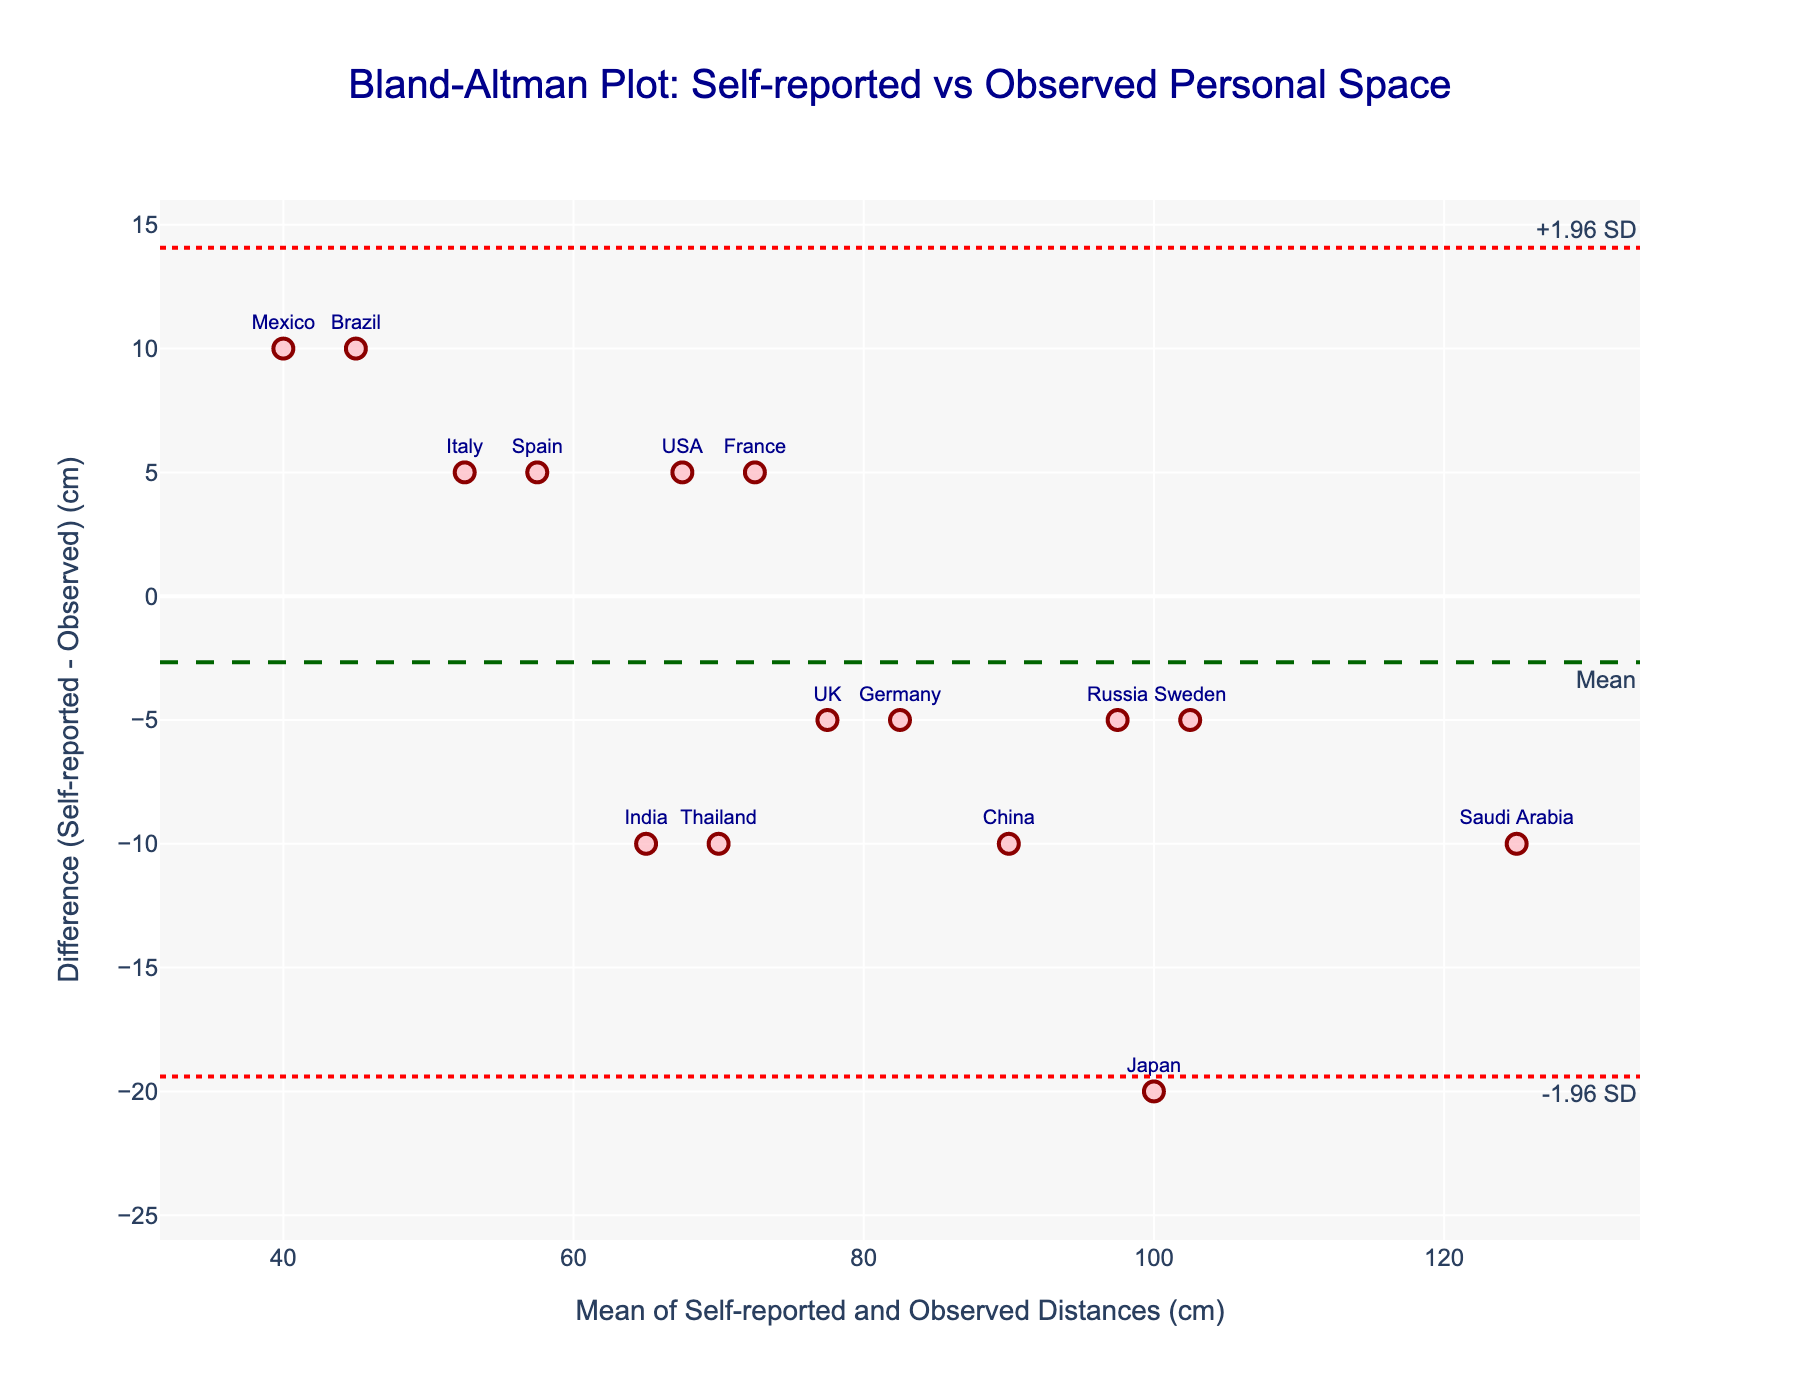What is the title of the figure? The title is prominently displayed at the top of the figure in larger font and blue color.
Answer: Bland-Altman Plot: Self-reported vs Observed Personal Space What does the x-axis represent? The x-axis title can be seen below the axis, describing what it measures in the plot.
Answer: Mean of Self-reported and Observed Distances (cm) What does the y-axis represent? The y-axis title is found on the left side of the axis, explaining the measurement used on this axis.
Answer: Difference (Self-reported - Observed) (cm) How many data points are there in the figure? By counting the number of markers or cultures listed, we determine the number of data points.
Answer: 15 Which culture has the smallest observed personal space compared to its self-reported distance? We identify the culture with the largest negative difference by looking at the y-axis values labeled with culture names.
Answer: Mexico Which culture has the highest mean distance between self-reported and observed distances? By determining which data point has the highest x-axis value, representing the mean distance.
Answer: Saudi Arabia What is the mean difference between self-reported and observed distances? The mean difference is indicated by a dashed horizontal line labeled "Mean".
Answer: Approximately -0.67 cm What are the limits of agreement on the plot? The limits are shown by dotted horizontal lines, labeled as "-1.96 SD" and "+1.96 SD".
Answer: Approximately -20 cm and 18.67 cm Which culture has the largest positive difference between self-reported and observed distances? By locating the data point with the highest y-value on the plot and checking which culture it's labeled with.
Answer: Brazil Are there any cultures for which the observed personal space is exactly the same as the self-reported distance? By finding data points where the difference (y-axis) is zero.
Answer: No 